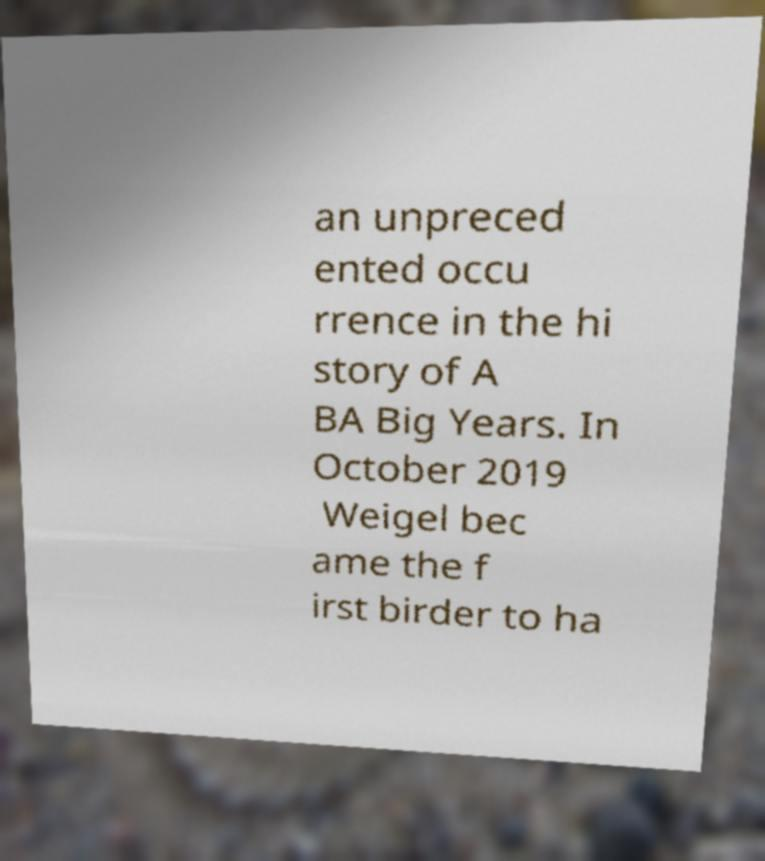There's text embedded in this image that I need extracted. Can you transcribe it verbatim? an unpreced ented occu rrence in the hi story of A BA Big Years. In October 2019 Weigel bec ame the f irst birder to ha 